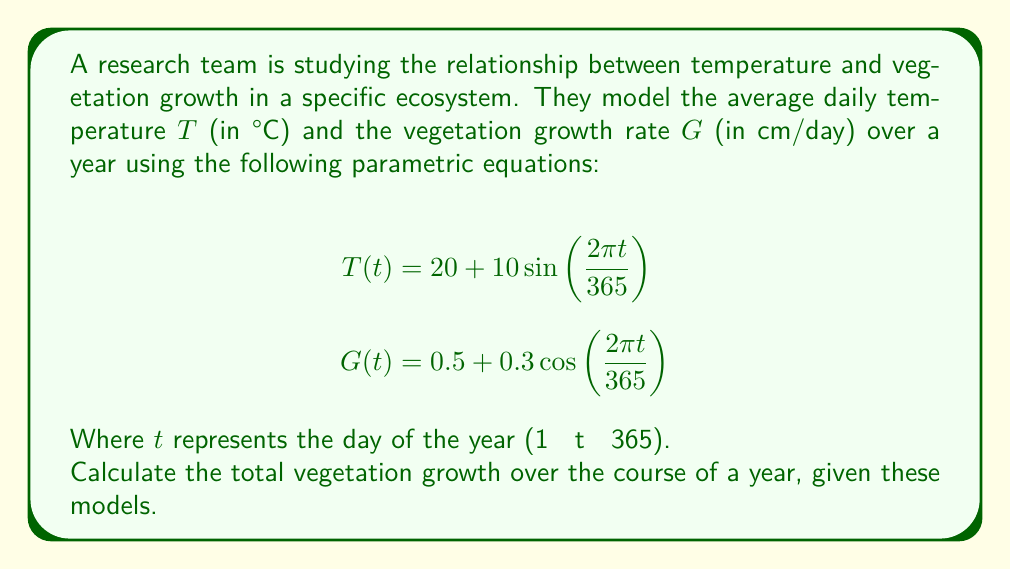Help me with this question. To solve this problem, we need to integrate the vegetation growth rate $G(t)$ over the entire year. Here's a step-by-step approach:

1) The total growth is given by the definite integral of $G(t)$ from $t = 1$ to $t = 365$:

   $$\text{Total Growth} = \int_{1}^{365} G(t) dt$$

2) Substituting the given equation for $G(t)$:

   $$\text{Total Growth} = \int_{1}^{365} \left[0.5 + 0.3\cos\left(\frac{2\pi t}{365}\right)\right] dt$$

3) We can split this into two integrals:

   $$\text{Total Growth} = \int_{1}^{365} 0.5 dt + \int_{1}^{365} 0.3\cos\left(\frac{2\pi t}{365}\right) dt$$

4) The first integral is straightforward:

   $$\int_{1}^{365} 0.5 dt = 0.5t \bigg|_{1}^{365} = 0.5(365 - 1) = 182$$

5) For the second integral, we can use the substitution $u = \frac{2\pi t}{365}$:

   $$\int_{1}^{365} 0.3\cos\left(\frac{2\pi t}{365}\right) dt = \frac{0.3 \cdot 365}{2\pi} \int_{\frac{2\pi}{365}}^{2\pi} \cos(u) du$$

6) Evaluating this integral:

   $$\frac{0.3 \cdot 365}{2\pi} \left[\sin(u)\right]_{\frac{2\pi}{365}}^{2\pi} = \frac{0.3 \cdot 365}{2\pi} \left[\sin(2\pi) - \sin\left(\frac{2\pi}{365}\right)\right] = -\frac{0.3 \cdot 365}{2\pi} \sin\left(\frac{2\pi}{365}\right)$$

7) The total growth is the sum of these two parts:

   $$\text{Total Growth} = 182 - \frac{0.3 \cdot 365}{2\pi} \sin\left(\frac{2\pi}{365}\right)$$

8) Evaluating this numerically (you can use a calculator for this step):

   $$\text{Total Growth} \approx 182 - 0.0052 \approx 181.9948 \text{ cm}$$
Answer: The total vegetation growth over the course of a year is approximately 181.9948 cm. 